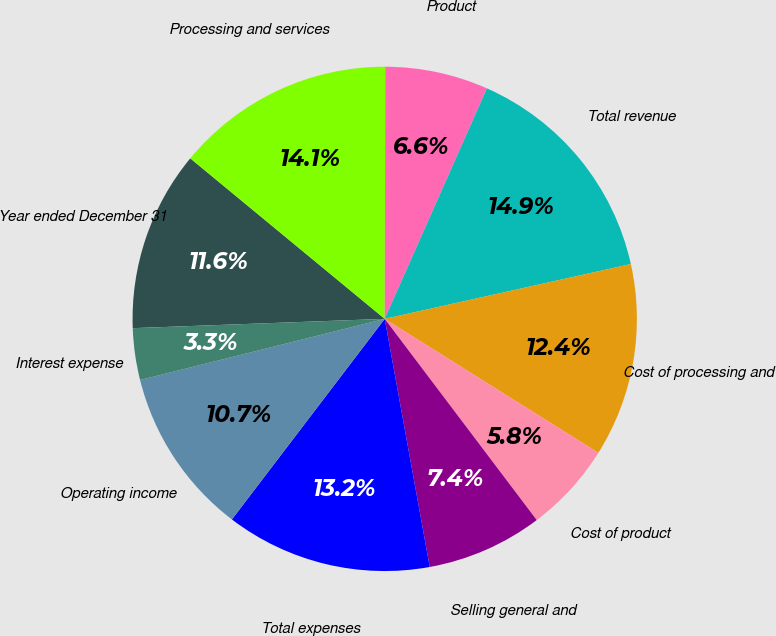<chart> <loc_0><loc_0><loc_500><loc_500><pie_chart><fcel>Year ended December 31<fcel>Processing and services<fcel>Product<fcel>Total revenue<fcel>Cost of processing and<fcel>Cost of product<fcel>Selling general and<fcel>Total expenses<fcel>Operating income<fcel>Interest expense<nl><fcel>11.57%<fcel>14.05%<fcel>6.61%<fcel>14.87%<fcel>12.4%<fcel>5.79%<fcel>7.44%<fcel>13.22%<fcel>10.74%<fcel>3.31%<nl></chart> 